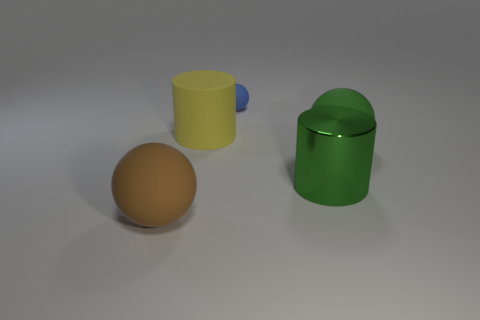There is a big object behind the big rubber sphere behind the brown sphere; what shape is it?
Keep it short and to the point. Cylinder. There is a big object behind the green matte thing; what shape is it?
Make the answer very short. Cylinder. How many shiny objects are the same color as the big matte cylinder?
Your answer should be compact. 0. What is the color of the large rubber cylinder?
Ensure brevity in your answer.  Yellow. How many big brown rubber spheres are in front of the big ball on the right side of the yellow rubber object?
Your answer should be very brief. 1. There is a metal cylinder; is its size the same as the ball that is left of the blue rubber object?
Your answer should be compact. Yes. Do the yellow cylinder and the green matte sphere have the same size?
Give a very brief answer. Yes. Is there a green thing that has the same size as the matte cylinder?
Offer a very short reply. Yes. There is a large cylinder that is to the right of the blue rubber ball; what is it made of?
Ensure brevity in your answer.  Metal. The large cylinder that is the same material as the blue object is what color?
Offer a very short reply. Yellow. 